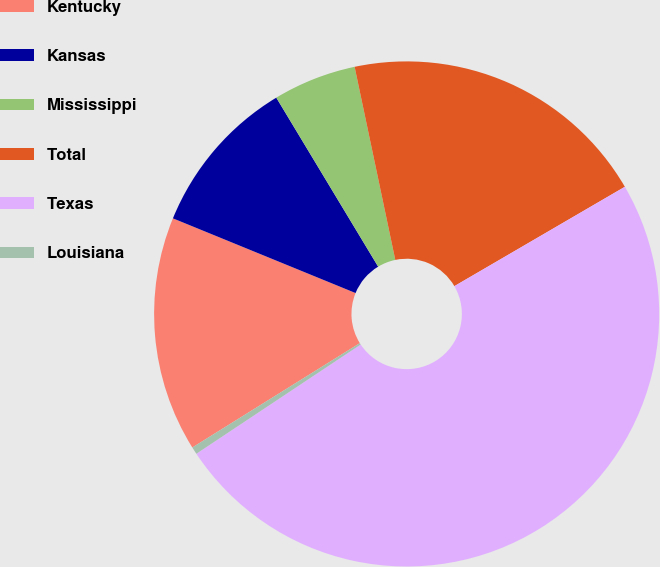Convert chart to OTSL. <chart><loc_0><loc_0><loc_500><loc_500><pie_chart><fcel>Kentucky<fcel>Kansas<fcel>Mississippi<fcel>Total<fcel>Texas<fcel>Louisiana<nl><fcel>15.05%<fcel>10.19%<fcel>5.33%<fcel>19.91%<fcel>49.07%<fcel>0.47%<nl></chart> 